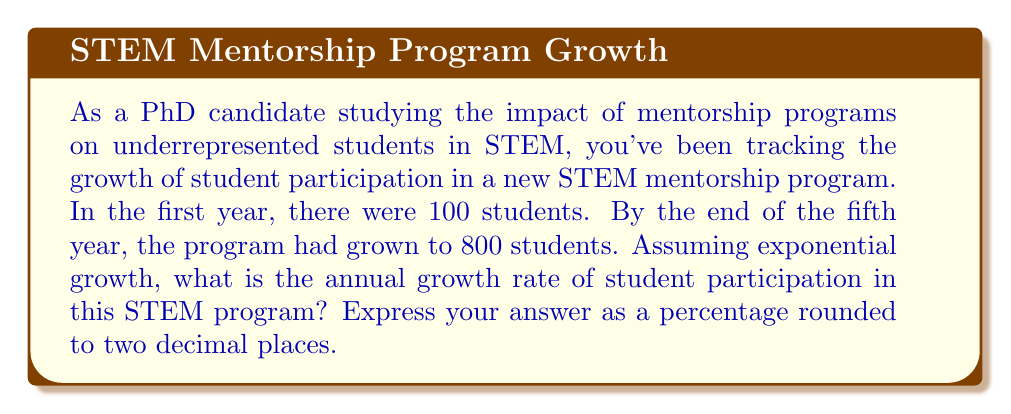Provide a solution to this math problem. To solve this problem, we'll use the exponential growth formula:

$$A = P(1 + r)^t$$

Where:
$A$ = Final amount
$P$ = Initial amount
$r$ = Annual growth rate (in decimal form)
$t$ = Time (in years)

Given:
$P = 100$ (initial number of students)
$A = 800$ (final number of students after 5 years)
$t = 5$ years

Step 1: Substitute the known values into the formula.
$$800 = 100(1 + r)^5$$

Step 2: Divide both sides by 100.
$$8 = (1 + r)^5$$

Step 3: Take the fifth root of both sides.
$$\sqrt[5]{8} = 1 + r$$

Step 4: Subtract 1 from both sides to isolate $r$.
$$\sqrt[5]{8} - 1 = r$$

Step 5: Calculate the value of $r$.
$$r \approx 1.5157 - 1 = 0.5157$$

Step 6: Convert $r$ to a percentage by multiplying by 100.
$$0.5157 \times 100 \approx 51.57\%$$

Step 7: Round to two decimal places.
$$51.57\% \approx 51.57\%$$
Answer: The annual growth rate of student participation in the STEM program is approximately 51.57%. 